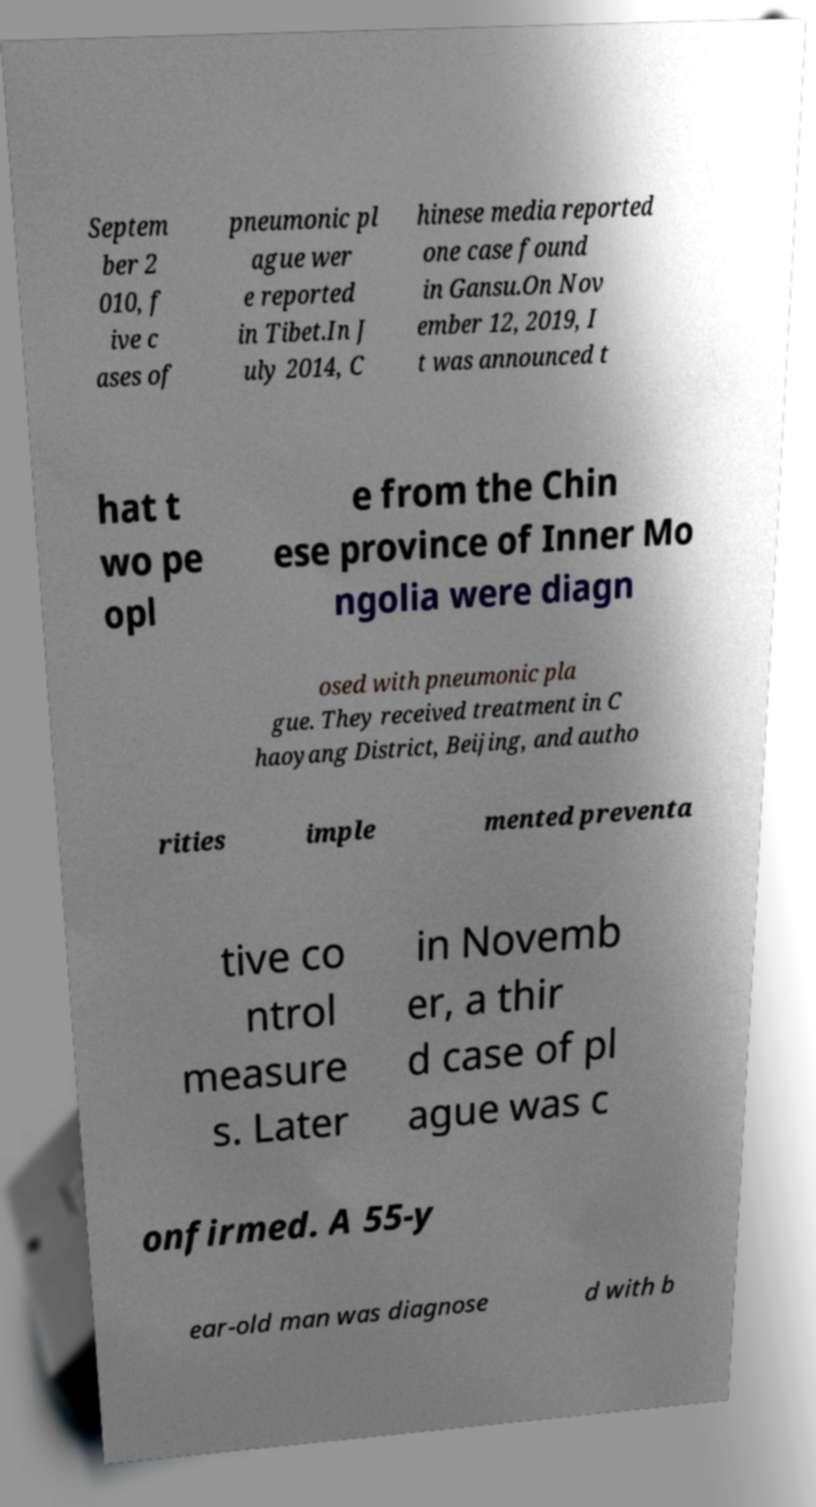Could you assist in decoding the text presented in this image and type it out clearly? Septem ber 2 010, f ive c ases of pneumonic pl ague wer e reported in Tibet.In J uly 2014, C hinese media reported one case found in Gansu.On Nov ember 12, 2019, I t was announced t hat t wo pe opl e from the Chin ese province of Inner Mo ngolia were diagn osed with pneumonic pla gue. They received treatment in C haoyang District, Beijing, and autho rities imple mented preventa tive co ntrol measure s. Later in Novemb er, a thir d case of pl ague was c onfirmed. A 55-y ear-old man was diagnose d with b 